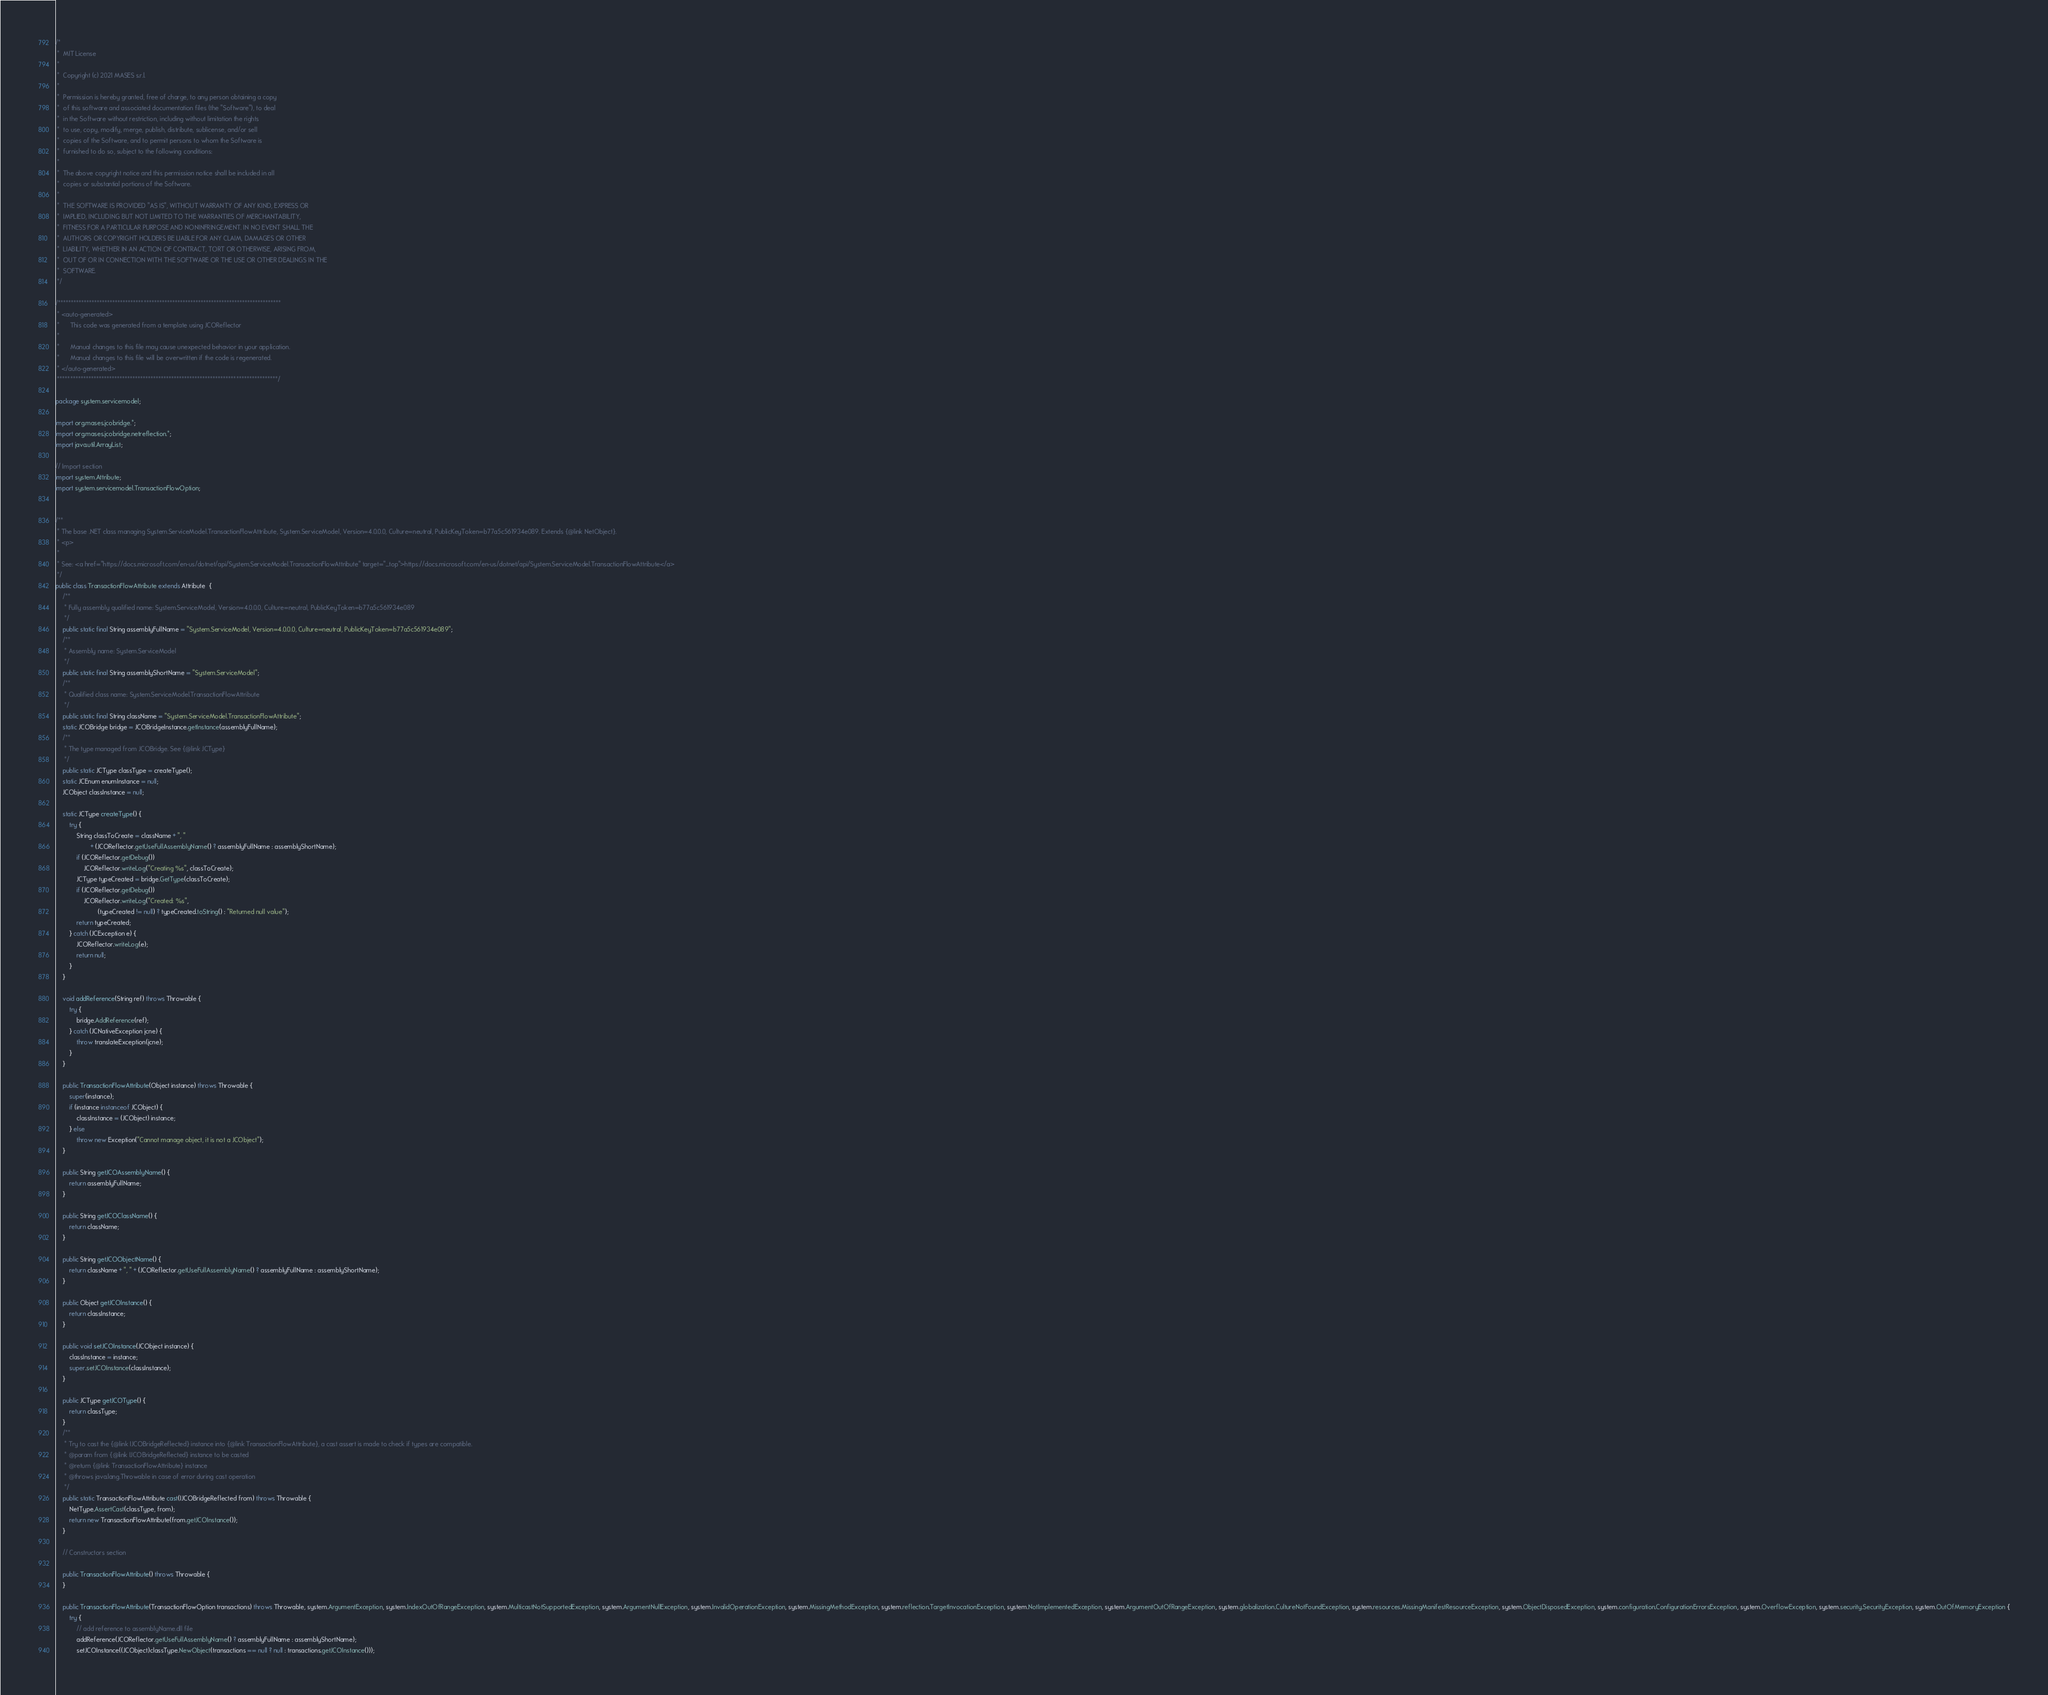<code> <loc_0><loc_0><loc_500><loc_500><_Java_>/*
 *  MIT License
 *
 *  Copyright (c) 2021 MASES s.r.l.
 *
 *  Permission is hereby granted, free of charge, to any person obtaining a copy
 *  of this software and associated documentation files (the "Software"), to deal
 *  in the Software without restriction, including without limitation the rights
 *  to use, copy, modify, merge, publish, distribute, sublicense, and/or sell
 *  copies of the Software, and to permit persons to whom the Software is
 *  furnished to do so, subject to the following conditions:
 *
 *  The above copyright notice and this permission notice shall be included in all
 *  copies or substantial portions of the Software.
 *
 *  THE SOFTWARE IS PROVIDED "AS IS", WITHOUT WARRANTY OF ANY KIND, EXPRESS OR
 *  IMPLIED, INCLUDING BUT NOT LIMITED TO THE WARRANTIES OF MERCHANTABILITY,
 *  FITNESS FOR A PARTICULAR PURPOSE AND NONINFRINGEMENT. IN NO EVENT SHALL THE
 *  AUTHORS OR COPYRIGHT HOLDERS BE LIABLE FOR ANY CLAIM, DAMAGES OR OTHER
 *  LIABILITY, WHETHER IN AN ACTION OF CONTRACT, TORT OR OTHERWISE, ARISING FROM,
 *  OUT OF OR IN CONNECTION WITH THE SOFTWARE OR THE USE OR OTHER DEALINGS IN THE
 *  SOFTWARE.
 */

/**************************************************************************************
 * <auto-generated>
 *      This code was generated from a template using JCOReflector
 * 
 *      Manual changes to this file may cause unexpected behavior in your application.
 *      Manual changes to this file will be overwritten if the code is regenerated.
 * </auto-generated>
 *************************************************************************************/

package system.servicemodel;

import org.mases.jcobridge.*;
import org.mases.jcobridge.netreflection.*;
import java.util.ArrayList;

// Import section
import system.Attribute;
import system.servicemodel.TransactionFlowOption;


/**
 * The base .NET class managing System.ServiceModel.TransactionFlowAttribute, System.ServiceModel, Version=4.0.0.0, Culture=neutral, PublicKeyToken=b77a5c561934e089. Extends {@link NetObject}.
 * <p>
 * 
 * See: <a href="https://docs.microsoft.com/en-us/dotnet/api/System.ServiceModel.TransactionFlowAttribute" target="_top">https://docs.microsoft.com/en-us/dotnet/api/System.ServiceModel.TransactionFlowAttribute</a>
 */
public class TransactionFlowAttribute extends Attribute  {
    /**
     * Fully assembly qualified name: System.ServiceModel, Version=4.0.0.0, Culture=neutral, PublicKeyToken=b77a5c561934e089
     */
    public static final String assemblyFullName = "System.ServiceModel, Version=4.0.0.0, Culture=neutral, PublicKeyToken=b77a5c561934e089";
    /**
     * Assembly name: System.ServiceModel
     */
    public static final String assemblyShortName = "System.ServiceModel";
    /**
     * Qualified class name: System.ServiceModel.TransactionFlowAttribute
     */
    public static final String className = "System.ServiceModel.TransactionFlowAttribute";
    static JCOBridge bridge = JCOBridgeInstance.getInstance(assemblyFullName);
    /**
     * The type managed from JCOBridge. See {@link JCType}
     */
    public static JCType classType = createType();
    static JCEnum enumInstance = null;
    JCObject classInstance = null;

    static JCType createType() {
        try {
            String classToCreate = className + ", "
                    + (JCOReflector.getUseFullAssemblyName() ? assemblyFullName : assemblyShortName);
            if (JCOReflector.getDebug())
                JCOReflector.writeLog("Creating %s", classToCreate);
            JCType typeCreated = bridge.GetType(classToCreate);
            if (JCOReflector.getDebug())
                JCOReflector.writeLog("Created: %s",
                        (typeCreated != null) ? typeCreated.toString() : "Returned null value");
            return typeCreated;
        } catch (JCException e) {
            JCOReflector.writeLog(e);
            return null;
        }
    }

    void addReference(String ref) throws Throwable {
        try {
            bridge.AddReference(ref);
        } catch (JCNativeException jcne) {
            throw translateException(jcne);
        }
    }

    public TransactionFlowAttribute(Object instance) throws Throwable {
        super(instance);
        if (instance instanceof JCObject) {
            classInstance = (JCObject) instance;
        } else
            throw new Exception("Cannot manage object, it is not a JCObject");
    }

    public String getJCOAssemblyName() {
        return assemblyFullName;
    }

    public String getJCOClassName() {
        return className;
    }

    public String getJCOObjectName() {
        return className + ", " + (JCOReflector.getUseFullAssemblyName() ? assemblyFullName : assemblyShortName);
    }

    public Object getJCOInstance() {
        return classInstance;
    }

    public void setJCOInstance(JCObject instance) {
        classInstance = instance;
        super.setJCOInstance(classInstance);
    }

    public JCType getJCOType() {
        return classType;
    }
    /**
     * Try to cast the {@link IJCOBridgeReflected} instance into {@link TransactionFlowAttribute}, a cast assert is made to check if types are compatible.
     * @param from {@link IJCOBridgeReflected} instance to be casted
     * @return {@link TransactionFlowAttribute} instance
     * @throws java.lang.Throwable in case of error during cast operation
     */
    public static TransactionFlowAttribute cast(IJCOBridgeReflected from) throws Throwable {
        NetType.AssertCast(classType, from);
        return new TransactionFlowAttribute(from.getJCOInstance());
    }

    // Constructors section
    
    public TransactionFlowAttribute() throws Throwable {
    }

    public TransactionFlowAttribute(TransactionFlowOption transactions) throws Throwable, system.ArgumentException, system.IndexOutOfRangeException, system.MulticastNotSupportedException, system.ArgumentNullException, system.InvalidOperationException, system.MissingMethodException, system.reflection.TargetInvocationException, system.NotImplementedException, system.ArgumentOutOfRangeException, system.globalization.CultureNotFoundException, system.resources.MissingManifestResourceException, system.ObjectDisposedException, system.configuration.ConfigurationErrorsException, system.OverflowException, system.security.SecurityException, system.OutOfMemoryException {
        try {
            // add reference to assemblyName.dll file
            addReference(JCOReflector.getUseFullAssemblyName() ? assemblyFullName : assemblyShortName);
            setJCOInstance((JCObject)classType.NewObject(transactions == null ? null : transactions.getJCOInstance()));</code> 